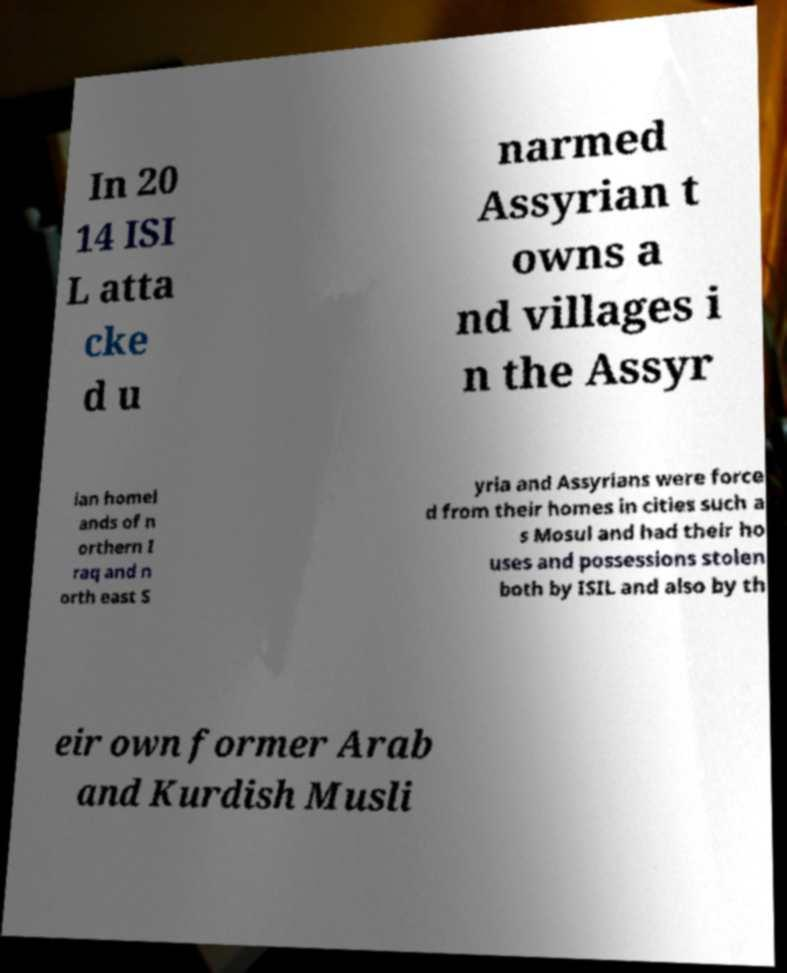Can you accurately transcribe the text from the provided image for me? In 20 14 ISI L atta cke d u narmed Assyrian t owns a nd villages i n the Assyr ian homel ands of n orthern I raq and n orth east S yria and Assyrians were force d from their homes in cities such a s Mosul and had their ho uses and possessions stolen both by ISIL and also by th eir own former Arab and Kurdish Musli 